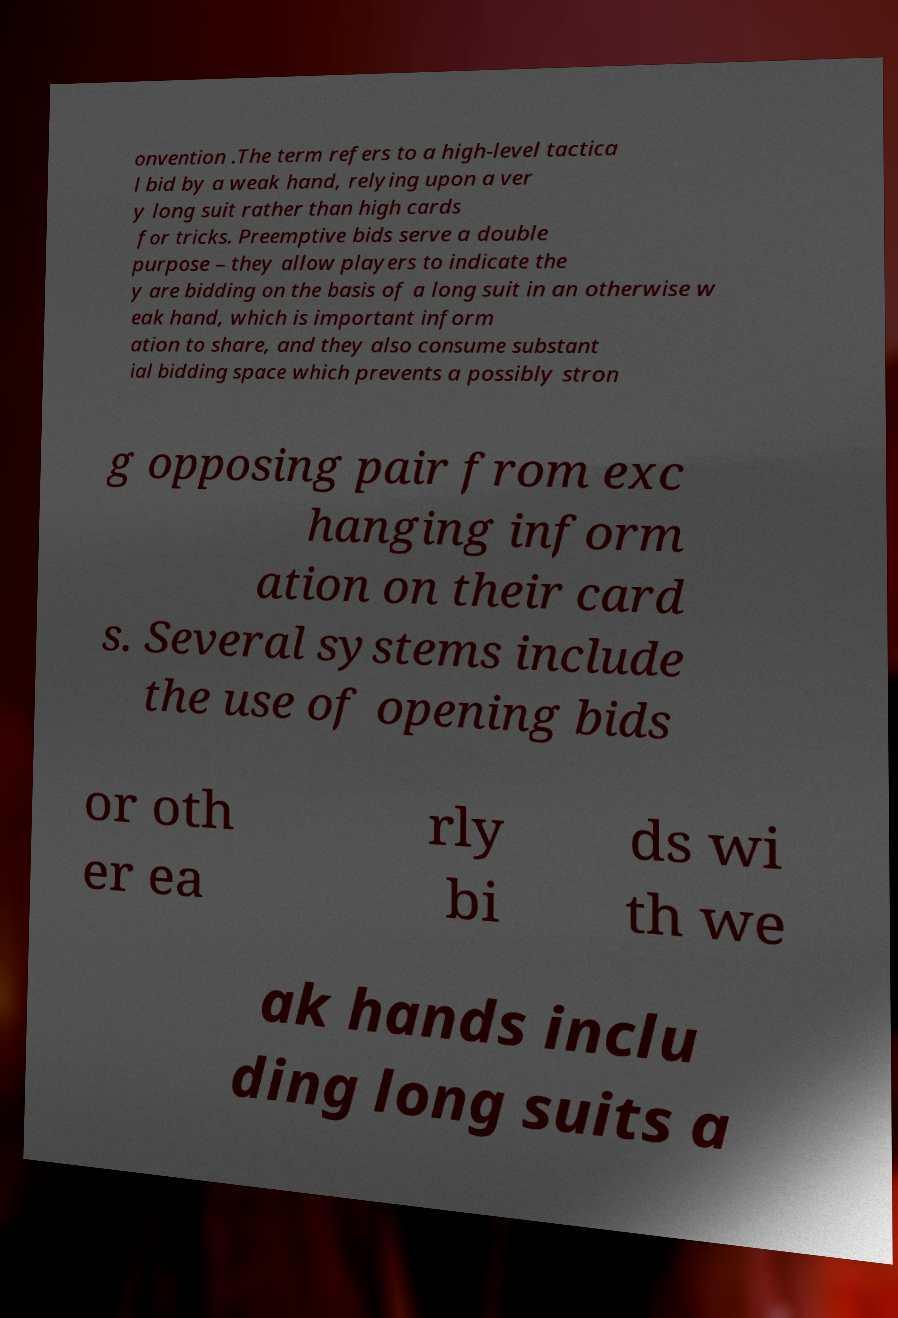There's text embedded in this image that I need extracted. Can you transcribe it verbatim? onvention .The term refers to a high-level tactica l bid by a weak hand, relying upon a ver y long suit rather than high cards for tricks. Preemptive bids serve a double purpose – they allow players to indicate the y are bidding on the basis of a long suit in an otherwise w eak hand, which is important inform ation to share, and they also consume substant ial bidding space which prevents a possibly stron g opposing pair from exc hanging inform ation on their card s. Several systems include the use of opening bids or oth er ea rly bi ds wi th we ak hands inclu ding long suits a 